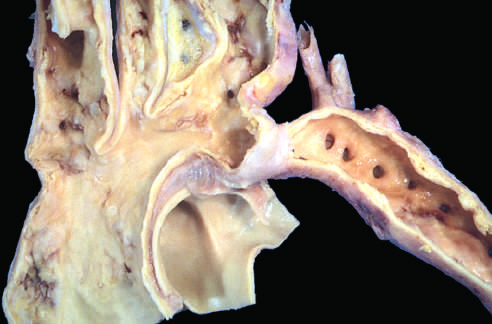re the lower extremities perfused predominantly by way of dilated, tortuous collateral channels?
Answer the question using a single word or phrase. Yes 